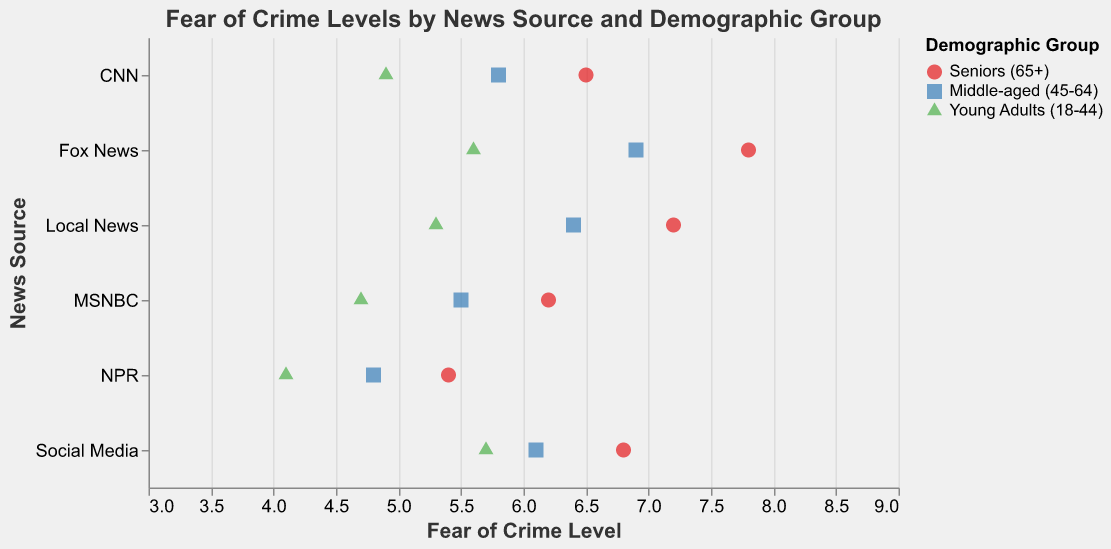What's the title of the figure? The title of the figure is prominently displayed at the top of the visual. It reads "Fear of Crime Levels by News Source and Demographic Group".
Answer: Fear of Crime Levels by News Source and Demographic Group Which news source shows the highest fear of crime level among seniors (65+)? By observing the data points, the highest fear of crime level among seniors (65+) is associated with "Fox News" which shows a value of 7.8.
Answer: Fox News Compare the fear of crime levels between "Middle-aged (45-64)" individuals who get news from "MSNBC" and those from "Social Media". Which group has a higher fear level? The fear of crime level for "Middle-aged (45-64)" individuals is 5.5 for "MSNBC" and 6.1 for "Social Media". Since 6.1 is greater than 5.5, those who get news from "Social Media" have a higher fear level.
Answer: Social Media What is the range of fear of crime levels for "Young Adults (18-44)" across different news sources? The fear of crime levels for "Young Adults (18-44)" are 5.6 (Fox News), 4.9 (CNN), 4.7 (MSNBC), 4.1 (NPR), 5.3 (Local News), and 5.7 (Social Media). The range is calculated as highest level (5.7) minus the lowest level (4.1), which is 5.7 - 4.1 = 1.6.
Answer: 1.6 Which demographic group has the lowest average fear of crime level across all news sources? To determine the lowest average fear level, calculate the average for each demographic group:
- Seniors (65+): (7.8 + 6.5 + 6.2 + 5.4 + 7.2 + 6.8) / 6 = 6.65
- Middle-aged (45-64): (6.9 + 5.8 + 5.5 + 4.8 + 6.4 + 6.1) / 6 = 5.91
- Young Adults (18-44): (5.6 + 4.9 + 4.7 + 4.1 + 5.3 + 5.7) / 6 = 5.05
Since 5.05 is the lowest, "Young Adults (18-44)" have the lowest average fear of crime level.
Answer: Young Adults (18-44) How does the fear of crime level trend as the age group gets younger for those relying on CNN? The fear of crime levels for CNN are 6.5 (Seniors 65+), 5.8 (Middle-aged 45-64), and 4.9 (Young Adults 18-44). The trend shows a decreasing pattern as the age group gets younger.
Answer: Decreasing What is the difference in fear of crime levels between individuals who get their news from "Local News" and "NPR" for the "Seniors (65+)" demographic? For Seniors (65+), the fear of crime level is 7.2 for "Local News" and 5.4 for "NPR". The difference is calculated as 7.2 - 5.4 = 1.8.
Answer: 1.8 Identify the news source with the lowest fear of crime level for "Middle-aged (45-64)" individuals. By inspecting the data points, "NPR" shows the lowest fear of crime level for "Middle-aged (45-64)" individuals with a value of 4.8.
Answer: NPR 